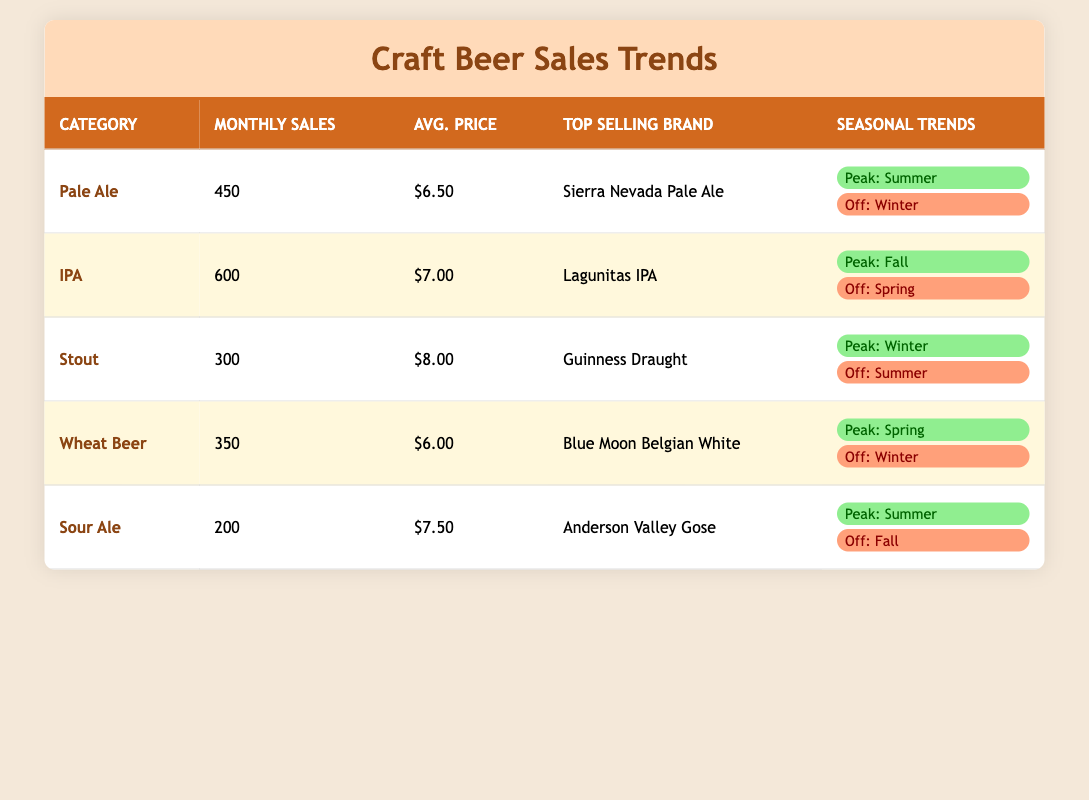What is the average monthly sales for the IPA category? The table indicates that the average monthly sales for the IPA category specifically lists a value of 600. Therefore, the average monthly sales for IPA is 600.
Answer: 600 Which category has the highest average price? To find this, we review the average prices listed: Pale Ale (6.50), IPA (7.00), Stout (8.00), Wheat Beer (6.00), and Sour Ale (7.50). The maximum price among these is for Stout, at 8.00.
Answer: Stout (8.00) True or False: The top-selling brand for Pale Ale is Blue Moon Belgian White. According to the table, the top-selling brand for Pale Ale is Sierra Nevada Pale Ale, not Blue Moon Belgian White. Thus, the statement is false.
Answer: False What is the peak season for Wheat Beer? The table directly states that the peak season for Wheat Beer is Spring. No additional calculations are needed here as it is clearly listed.
Answer: Spring If I sum the average monthly sales of Pale Ale and Stout, what do I get? The average monthly sales for Pale Ale is 450, and for Stout, it is 300. Adding these numbers together gives us 450 + 300 = 750. Therefore, the total is 750.
Answer: 750 Which category has the lowest average monthly sales? Examining the table, we see that the average monthly sales for the categories are as follows: Pale Ale (450), IPA (600), Stout (300), Wheat Beer (350), and Sour Ale (200). The lowest value is 200, which corresponds to the Sour Ale category.
Answer: Sour Ale What is the average price for the top-selling brand of IPAs? The average price listed for the IPA category is 7.00. Since this is the average price for all IPAs and corresponds to the top-selling brand Lagunitas IPA, the average remains 7.00.
Answer: 7.00 During which season is Sour Ale off-season? The table states that the off-season for Sour Ale is Fall. This is a direct retrieval from the seasonal trends provided in the table.
Answer: Fall 